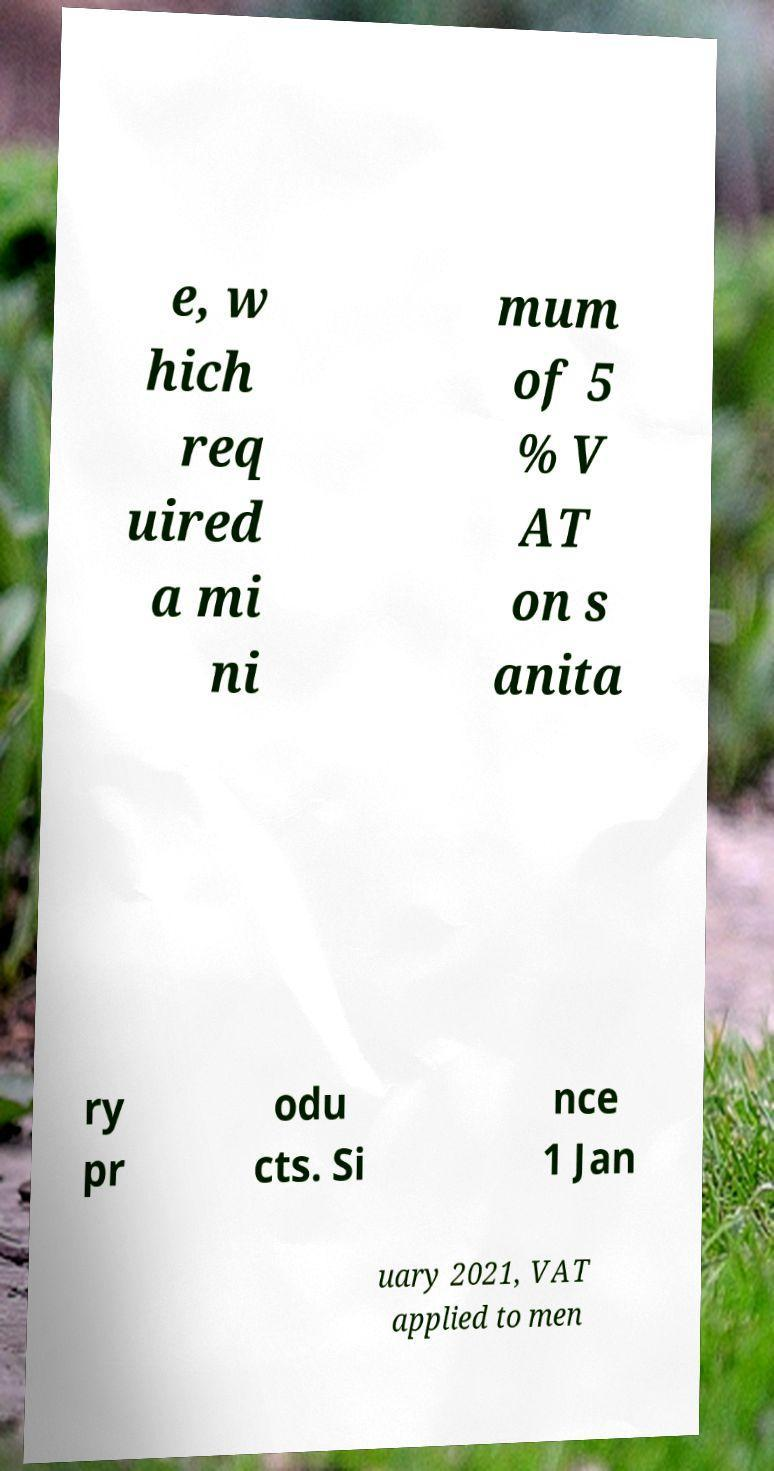I need the written content from this picture converted into text. Can you do that? e, w hich req uired a mi ni mum of 5 % V AT on s anita ry pr odu cts. Si nce 1 Jan uary 2021, VAT applied to men 